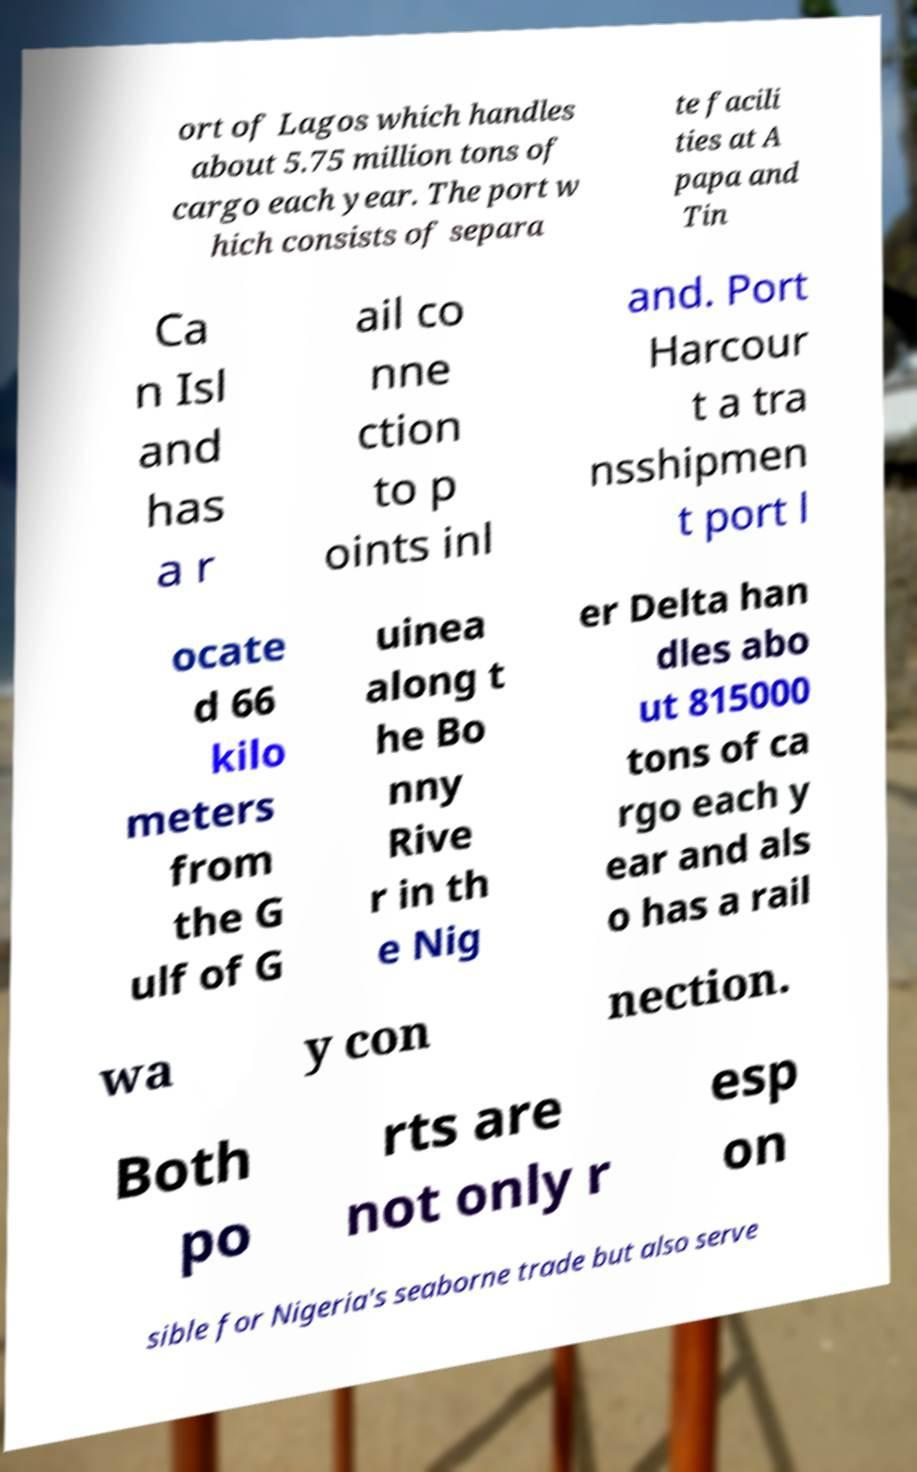Can you accurately transcribe the text from the provided image for me? ort of Lagos which handles about 5.75 million tons of cargo each year. The port w hich consists of separa te facili ties at A papa and Tin Ca n Isl and has a r ail co nne ction to p oints inl and. Port Harcour t a tra nsshipmen t port l ocate d 66 kilo meters from the G ulf of G uinea along t he Bo nny Rive r in th e Nig er Delta han dles abo ut 815000 tons of ca rgo each y ear and als o has a rail wa y con nection. Both po rts are not only r esp on sible for Nigeria's seaborne trade but also serve 